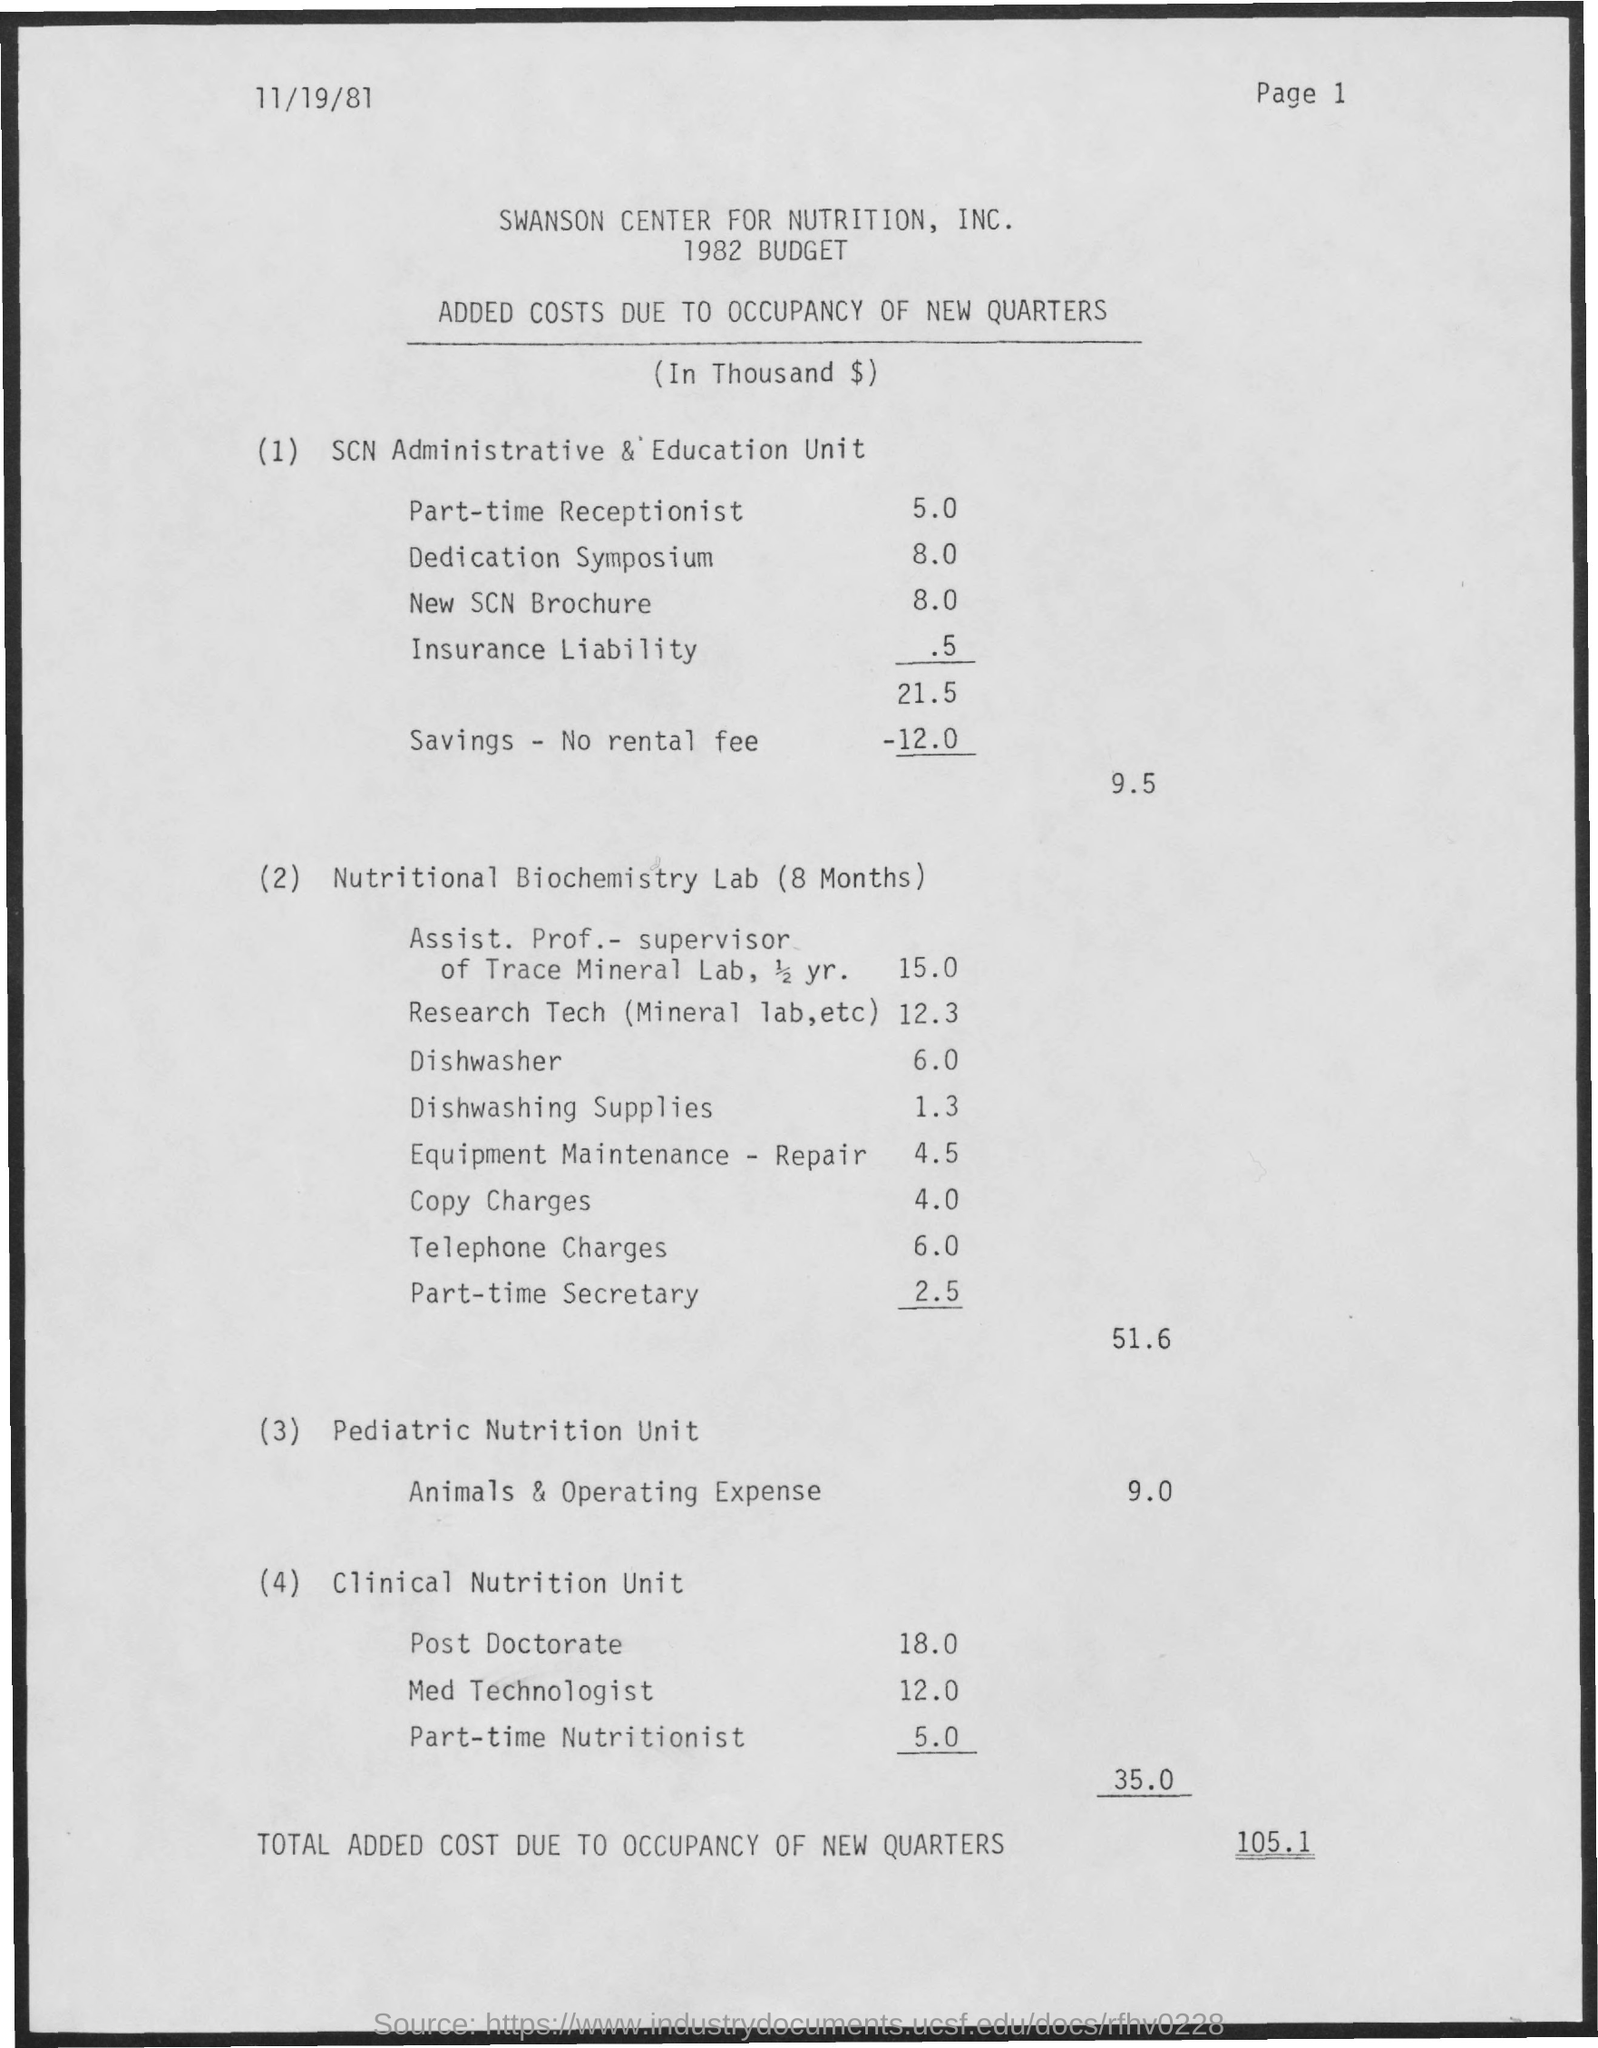What are the added costs due to occupancy of new quarters for Part-time Receptionist?
Keep it short and to the point. 5.0. What are the added costs due to occupancy of new quarters for Dedication Symposium?
Provide a short and direct response. 8.0. What are the added costs due to occupancy of new quarters for New SCN Brochure?
Your answer should be compact. 8.0. What are the added costs due to occupancy of new quarters for Insurance Liability?
Ensure brevity in your answer.  .5. What are the added costs due to occupancy of new quarters for Dishwasher?
Ensure brevity in your answer.  6.0. What are the added costs due to occupancy of new quarters for Dishwashing supplies?
Your answer should be very brief. 1.3. What are the added costs due to occupancy of new quarters for Part-time secretary?
Make the answer very short. 2.5. What are the added costs due to occupancy of new quarters for part-Time Nutritionist?
Provide a short and direct response. 5.0. What are the added costs due to occupancy of new quarters for med Technologist?
Provide a succinct answer. 12.0. 